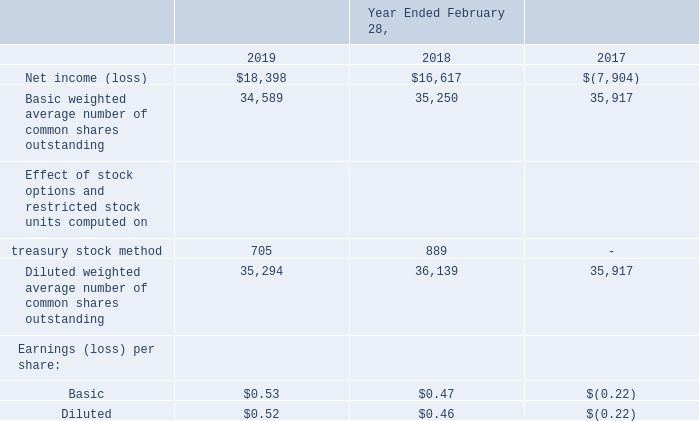NOTE 14 – EARNINGS (LOSS) PER SHARE
Basic earnings (loss) per share is computed by dividing net income (loss) by the weighted average number of common shares outstanding during the period. Diluted earnings per share is computed by dividing net income by the weighted average number of common shares outstanding during the period plus the dilutive effect of outstanding stock options and restricted stock-based awards using the treasury stock method. The following table sets forth the computation of basic and diluted earnings (loss) per share (in thousands, except per share amounts):
All outstanding stock options and restricted stock-based awards in the amount of 1.0 million and 1.2 million, respectively, were excluded from the computation of diluted earnings per share for the fiscal year ended February 28, 2017 because the effect of inclusion would be antidilutive. Shares subject to anti-dilutive stock options and restricted stock-based awards of 1.9 million and 0.2 million for the fiscal years ended February 28, 2019 and 2018, respectively, were excluded from the calculations of diluted earnings per share for the years then ended.
We have the option to pay cash, issue shares of common stock or any combination thereof for the aggregate amount due upon conversion of the Notes. It is our intent to settle the principal amount of the convertible senior notes with cash, and therefore, we use the treasury stock method for calculating any potential dilutive effect of the conversion option on diluted net income (loss) per share. From the time of the issuance of the Notes, the average market price of our common stock has been less than the initial conversion price of the Notes, and consequently no shares have been included in diluted earnings per share for the conversion value of the Notes.
How was basic earnings (loss) per share computed? Dividing net income (loss) by the weighted average number of common shares outstanding during the period. What was the net income(loss) in 2019?
Answer scale should be: thousand. $18,398. What was the net income(loss) in 2018?
Answer scale should be: thousand. $16,617. What was the percentage change in net income(loss) between 2018 and 2019?
Answer scale should be: percent. (18,398-16,617)/16,617
Answer: 10.72. What was the percentage change in Basic weighted average number of common shares outstanding between 2018 and 2019?
Answer scale should be: percent. (34,589-35,250)/35,250
Answer: -1.88. What is the change in Basic earnings(loss) per share between 2018 and 2019? (0.53-0.47)
Answer: 0.06. 